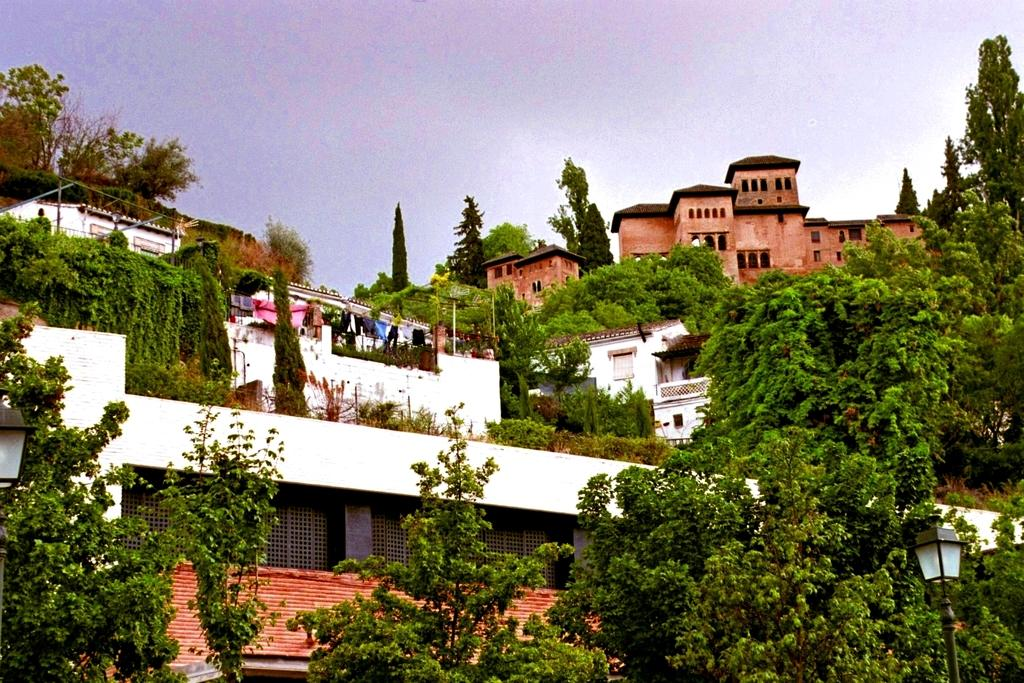What type of natural elements can be seen in the image? There are trees and plants in the image. What type of man-made structures are present in the image? There are houses in the image. What can be seen in the background of the image? The sky is visible in the background of the image. What type of machine or engine can be seen in the image? There is no machine or engine present in the image. Is there a tiger visible in the image? There is no tiger present in the image. 